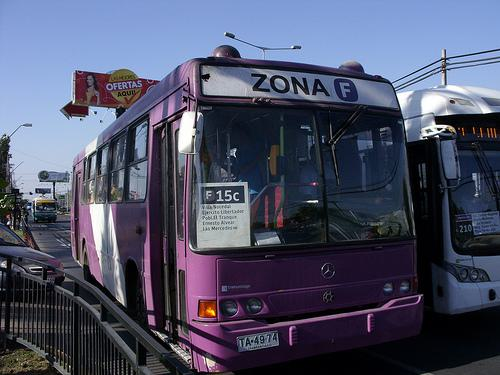Can you describe the surroundings where the bus is located? Certainly! The bus is on a road delimited by barriers, indicating a designated bus lane or stop. In the background, you can see a sign advertising 'OFERTAS AQUI' ('offers here'), hinting at nearby commercial activity. There are also other buses in close proximity, suggesting a bus station or a congested area where multiple transit routes intersect. 